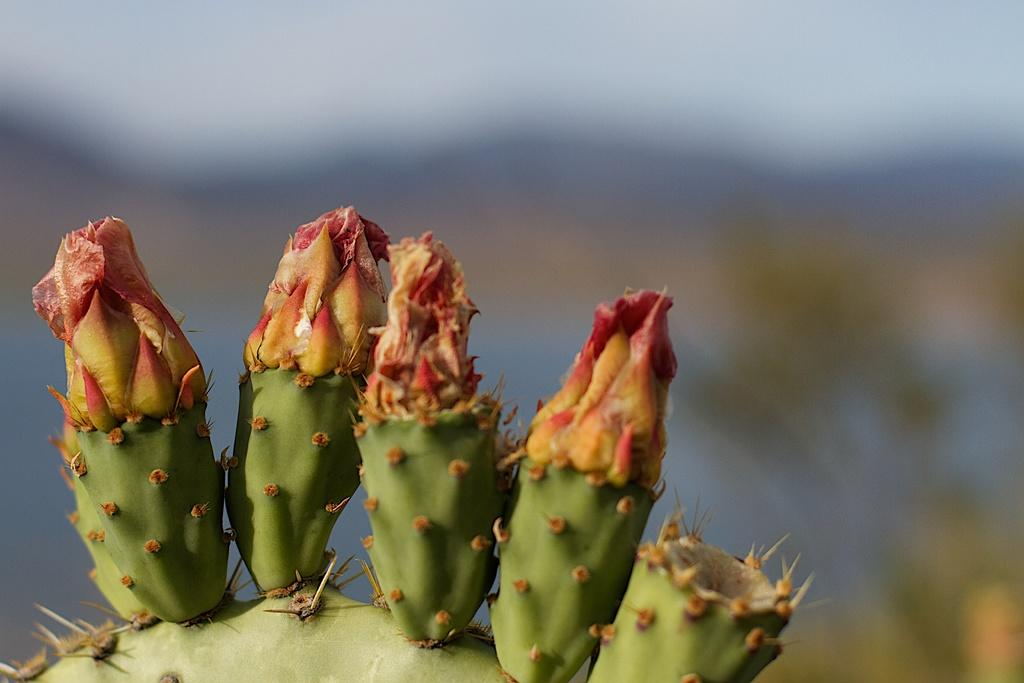What type of plant is in the image? There is a cactus plant in the image. How is the cactus plant positioned in the image? The cactus plant is truncated towards the bottom of the image. Can you describe the background of the image? The background of the image is blurred. What type of table is visible in the image? There is no table present in the image; it features a cactus plant with a blurred background. How many rays can be seen emanating from the cactus plant in the image? There are no rays visible in the image; it only shows a cactus plant and a blurred background. 